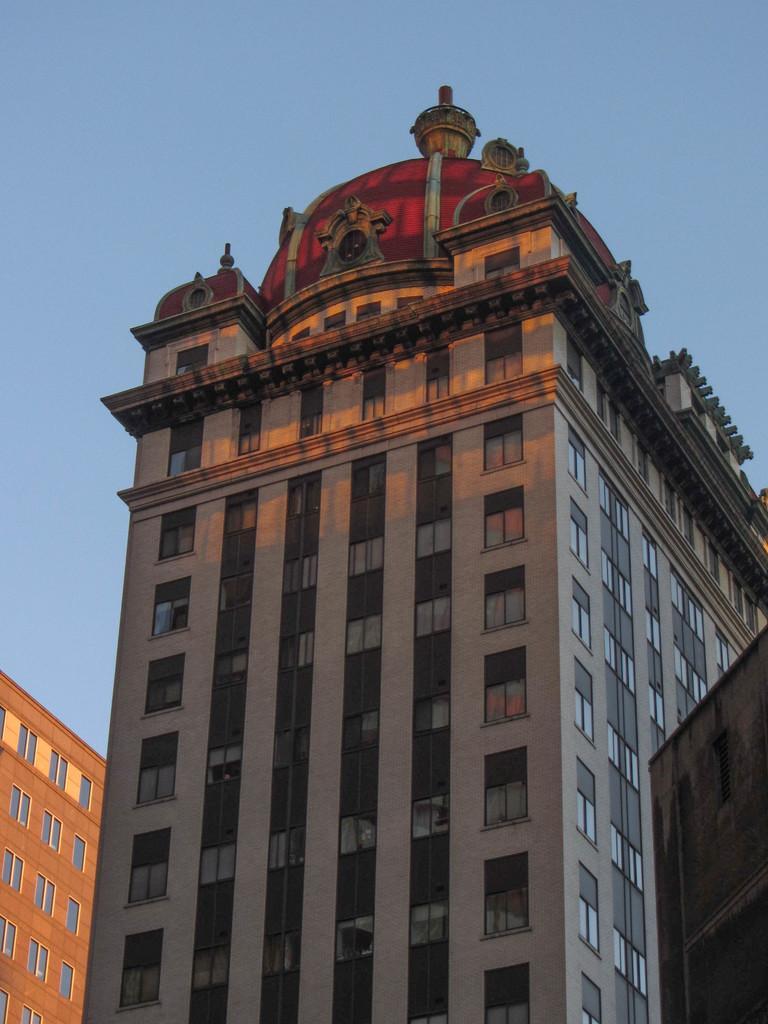Can you describe this image briefly? In this image we can see a few buildings there are some windows and in the background we can see the sky. 